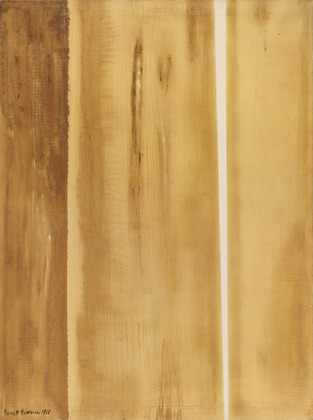If this painting could tell a story, what would it be about? This painting might tell the tale of a desolate desert at dawn. The vertical stripes could represent pillars of rock or trees, outlined against the golden light of sunrise that bathes the landscape in warm hues. Each line speaks of resilience and solitude, standing tall in the quiet stillness of the morning. The rough textures hint at the wear and tear of time, perhaps suggesting the enduring but eroded qualities of ancient formations—guardians of the secrets of time. 